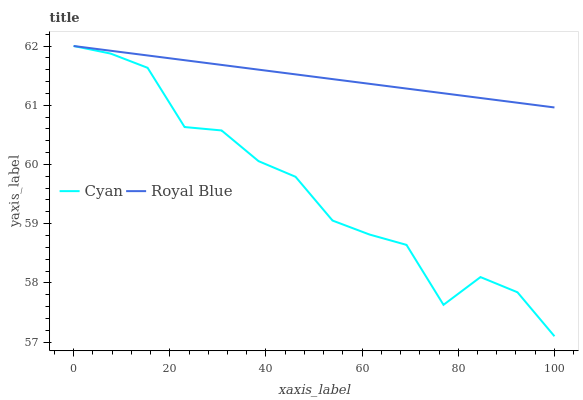Does Royal Blue have the minimum area under the curve?
Answer yes or no. No. Is Royal Blue the roughest?
Answer yes or no. No. Does Royal Blue have the lowest value?
Answer yes or no. No. 